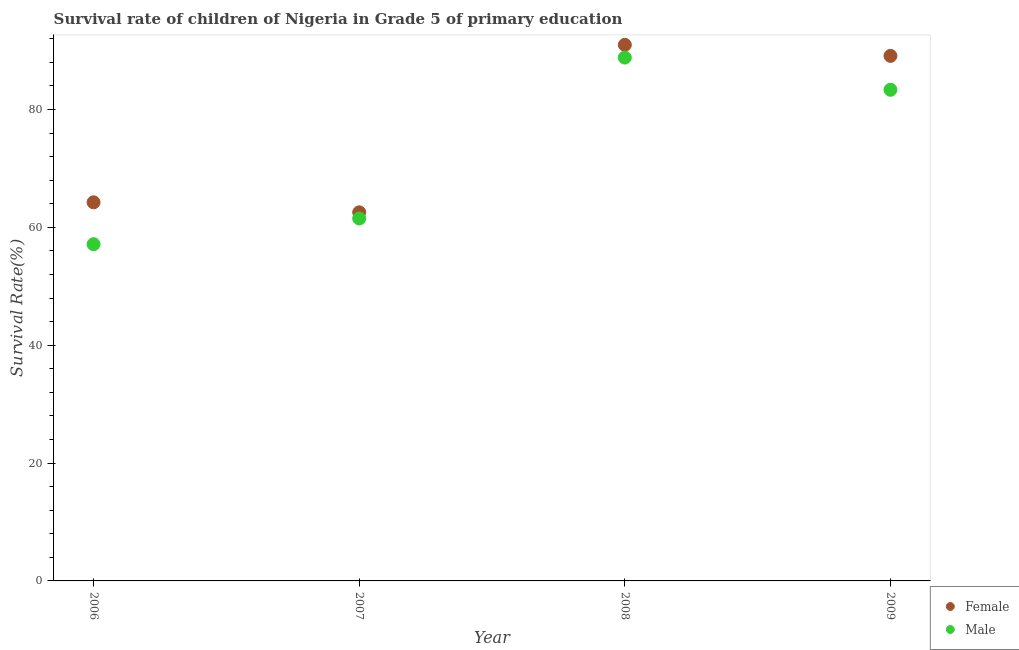What is the survival rate of female students in primary education in 2007?
Make the answer very short. 62.55. Across all years, what is the maximum survival rate of female students in primary education?
Offer a very short reply. 90.98. Across all years, what is the minimum survival rate of female students in primary education?
Offer a terse response. 62.55. What is the total survival rate of female students in primary education in the graph?
Give a very brief answer. 306.89. What is the difference between the survival rate of male students in primary education in 2007 and that in 2008?
Provide a succinct answer. -27.31. What is the difference between the survival rate of male students in primary education in 2007 and the survival rate of female students in primary education in 2006?
Your answer should be very brief. -2.74. What is the average survival rate of female students in primary education per year?
Offer a terse response. 76.72. In the year 2008, what is the difference between the survival rate of male students in primary education and survival rate of female students in primary education?
Give a very brief answer. -2.16. What is the ratio of the survival rate of female students in primary education in 2006 to that in 2009?
Provide a succinct answer. 0.72. Is the survival rate of male students in primary education in 2007 less than that in 2008?
Keep it short and to the point. Yes. What is the difference between the highest and the second highest survival rate of female students in primary education?
Your answer should be compact. 1.87. What is the difference between the highest and the lowest survival rate of female students in primary education?
Your answer should be compact. 28.42. Does the survival rate of female students in primary education monotonically increase over the years?
Your answer should be compact. No. Is the survival rate of male students in primary education strictly greater than the survival rate of female students in primary education over the years?
Offer a very short reply. No. How many dotlines are there?
Make the answer very short. 2. How many years are there in the graph?
Make the answer very short. 4. Are the values on the major ticks of Y-axis written in scientific E-notation?
Your response must be concise. No. Does the graph contain any zero values?
Your answer should be very brief. No. Does the graph contain grids?
Provide a succinct answer. No. How many legend labels are there?
Your answer should be compact. 2. How are the legend labels stacked?
Offer a very short reply. Vertical. What is the title of the graph?
Keep it short and to the point. Survival rate of children of Nigeria in Grade 5 of primary education. Does "Banks" appear as one of the legend labels in the graph?
Make the answer very short. No. What is the label or title of the Y-axis?
Your answer should be very brief. Survival Rate(%). What is the Survival Rate(%) of Female in 2006?
Keep it short and to the point. 64.25. What is the Survival Rate(%) in Male in 2006?
Give a very brief answer. 57.14. What is the Survival Rate(%) of Female in 2007?
Offer a very short reply. 62.55. What is the Survival Rate(%) of Male in 2007?
Give a very brief answer. 61.51. What is the Survival Rate(%) of Female in 2008?
Provide a short and direct response. 90.98. What is the Survival Rate(%) of Male in 2008?
Provide a succinct answer. 88.82. What is the Survival Rate(%) in Female in 2009?
Offer a very short reply. 89.1. What is the Survival Rate(%) in Male in 2009?
Your answer should be very brief. 83.35. Across all years, what is the maximum Survival Rate(%) in Female?
Give a very brief answer. 90.98. Across all years, what is the maximum Survival Rate(%) in Male?
Your answer should be very brief. 88.82. Across all years, what is the minimum Survival Rate(%) in Female?
Provide a short and direct response. 62.55. Across all years, what is the minimum Survival Rate(%) in Male?
Offer a very short reply. 57.14. What is the total Survival Rate(%) in Female in the graph?
Offer a terse response. 306.89. What is the total Survival Rate(%) in Male in the graph?
Offer a very short reply. 290.82. What is the difference between the Survival Rate(%) of Female in 2006 and that in 2007?
Ensure brevity in your answer.  1.7. What is the difference between the Survival Rate(%) of Male in 2006 and that in 2007?
Ensure brevity in your answer.  -4.37. What is the difference between the Survival Rate(%) of Female in 2006 and that in 2008?
Ensure brevity in your answer.  -26.72. What is the difference between the Survival Rate(%) of Male in 2006 and that in 2008?
Your answer should be compact. -31.67. What is the difference between the Survival Rate(%) of Female in 2006 and that in 2009?
Make the answer very short. -24.85. What is the difference between the Survival Rate(%) of Male in 2006 and that in 2009?
Make the answer very short. -26.21. What is the difference between the Survival Rate(%) of Female in 2007 and that in 2008?
Your answer should be compact. -28.42. What is the difference between the Survival Rate(%) of Male in 2007 and that in 2008?
Your answer should be compact. -27.31. What is the difference between the Survival Rate(%) in Female in 2007 and that in 2009?
Offer a terse response. -26.55. What is the difference between the Survival Rate(%) in Male in 2007 and that in 2009?
Provide a short and direct response. -21.84. What is the difference between the Survival Rate(%) of Female in 2008 and that in 2009?
Ensure brevity in your answer.  1.87. What is the difference between the Survival Rate(%) of Male in 2008 and that in 2009?
Give a very brief answer. 5.47. What is the difference between the Survival Rate(%) of Female in 2006 and the Survival Rate(%) of Male in 2007?
Provide a succinct answer. 2.74. What is the difference between the Survival Rate(%) of Female in 2006 and the Survival Rate(%) of Male in 2008?
Make the answer very short. -24.56. What is the difference between the Survival Rate(%) of Female in 2006 and the Survival Rate(%) of Male in 2009?
Provide a short and direct response. -19.1. What is the difference between the Survival Rate(%) in Female in 2007 and the Survival Rate(%) in Male in 2008?
Your answer should be very brief. -26.26. What is the difference between the Survival Rate(%) in Female in 2007 and the Survival Rate(%) in Male in 2009?
Your answer should be compact. -20.8. What is the difference between the Survival Rate(%) of Female in 2008 and the Survival Rate(%) of Male in 2009?
Make the answer very short. 7.63. What is the average Survival Rate(%) of Female per year?
Offer a very short reply. 76.72. What is the average Survival Rate(%) in Male per year?
Make the answer very short. 72.71. In the year 2006, what is the difference between the Survival Rate(%) in Female and Survival Rate(%) in Male?
Give a very brief answer. 7.11. In the year 2007, what is the difference between the Survival Rate(%) of Female and Survival Rate(%) of Male?
Ensure brevity in your answer.  1.04. In the year 2008, what is the difference between the Survival Rate(%) of Female and Survival Rate(%) of Male?
Give a very brief answer. 2.16. In the year 2009, what is the difference between the Survival Rate(%) of Female and Survival Rate(%) of Male?
Offer a very short reply. 5.75. What is the ratio of the Survival Rate(%) in Female in 2006 to that in 2007?
Your answer should be very brief. 1.03. What is the ratio of the Survival Rate(%) in Male in 2006 to that in 2007?
Keep it short and to the point. 0.93. What is the ratio of the Survival Rate(%) in Female in 2006 to that in 2008?
Provide a short and direct response. 0.71. What is the ratio of the Survival Rate(%) in Male in 2006 to that in 2008?
Your answer should be very brief. 0.64. What is the ratio of the Survival Rate(%) of Female in 2006 to that in 2009?
Provide a succinct answer. 0.72. What is the ratio of the Survival Rate(%) of Male in 2006 to that in 2009?
Your answer should be very brief. 0.69. What is the ratio of the Survival Rate(%) of Female in 2007 to that in 2008?
Your answer should be compact. 0.69. What is the ratio of the Survival Rate(%) of Male in 2007 to that in 2008?
Provide a succinct answer. 0.69. What is the ratio of the Survival Rate(%) of Female in 2007 to that in 2009?
Make the answer very short. 0.7. What is the ratio of the Survival Rate(%) in Male in 2007 to that in 2009?
Keep it short and to the point. 0.74. What is the ratio of the Survival Rate(%) in Male in 2008 to that in 2009?
Ensure brevity in your answer.  1.07. What is the difference between the highest and the second highest Survival Rate(%) in Female?
Your answer should be compact. 1.87. What is the difference between the highest and the second highest Survival Rate(%) in Male?
Your response must be concise. 5.47. What is the difference between the highest and the lowest Survival Rate(%) in Female?
Keep it short and to the point. 28.42. What is the difference between the highest and the lowest Survival Rate(%) of Male?
Provide a succinct answer. 31.67. 